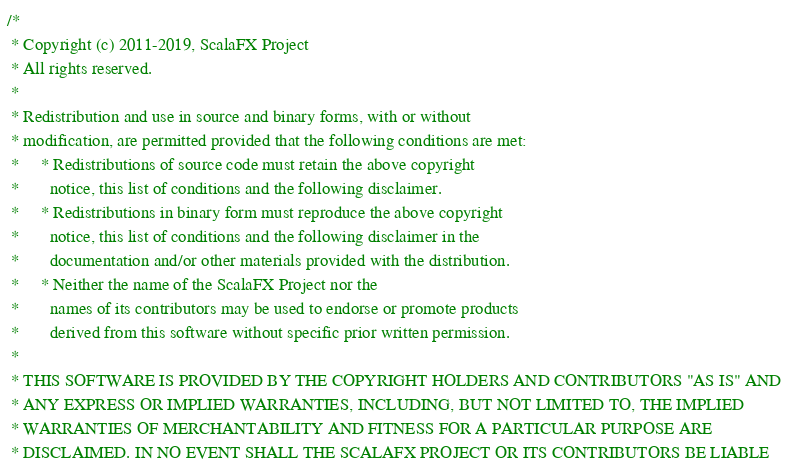Convert code to text. <code><loc_0><loc_0><loc_500><loc_500><_Scala_>/*
 * Copyright (c) 2011-2019, ScalaFX Project
 * All rights reserved.
 *
 * Redistribution and use in source and binary forms, with or without
 * modification, are permitted provided that the following conditions are met:
 *     * Redistributions of source code must retain the above copyright
 *       notice, this list of conditions and the following disclaimer.
 *     * Redistributions in binary form must reproduce the above copyright
 *       notice, this list of conditions and the following disclaimer in the
 *       documentation and/or other materials provided with the distribution.
 *     * Neither the name of the ScalaFX Project nor the
 *       names of its contributors may be used to endorse or promote products
 *       derived from this software without specific prior written permission.
 *
 * THIS SOFTWARE IS PROVIDED BY THE COPYRIGHT HOLDERS AND CONTRIBUTORS "AS IS" AND
 * ANY EXPRESS OR IMPLIED WARRANTIES, INCLUDING, BUT NOT LIMITED TO, THE IMPLIED
 * WARRANTIES OF MERCHANTABILITY AND FITNESS FOR A PARTICULAR PURPOSE ARE
 * DISCLAIMED. IN NO EVENT SHALL THE SCALAFX PROJECT OR ITS CONTRIBUTORS BE LIABLE</code> 